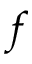<formula> <loc_0><loc_0><loc_500><loc_500>f</formula> 